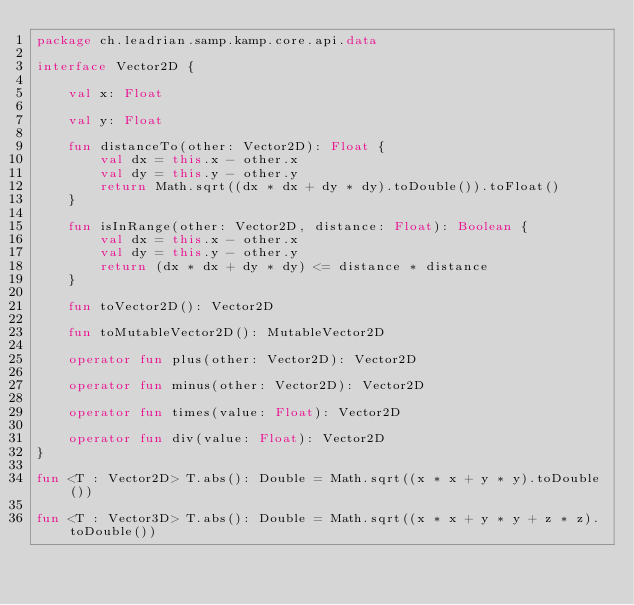Convert code to text. <code><loc_0><loc_0><loc_500><loc_500><_Kotlin_>package ch.leadrian.samp.kamp.core.api.data

interface Vector2D {

    val x: Float

    val y: Float

    fun distanceTo(other: Vector2D): Float {
        val dx = this.x - other.x
        val dy = this.y - other.y
        return Math.sqrt((dx * dx + dy * dy).toDouble()).toFloat()
    }

    fun isInRange(other: Vector2D, distance: Float): Boolean {
        val dx = this.x - other.x
        val dy = this.y - other.y
        return (dx * dx + dy * dy) <= distance * distance
    }

    fun toVector2D(): Vector2D

    fun toMutableVector2D(): MutableVector2D

    operator fun plus(other: Vector2D): Vector2D

    operator fun minus(other: Vector2D): Vector2D

    operator fun times(value: Float): Vector2D

    operator fun div(value: Float): Vector2D
}

fun <T : Vector2D> T.abs(): Double = Math.sqrt((x * x + y * y).toDouble())

fun <T : Vector3D> T.abs(): Double = Math.sqrt((x * x + y * y + z * z).toDouble())
</code> 